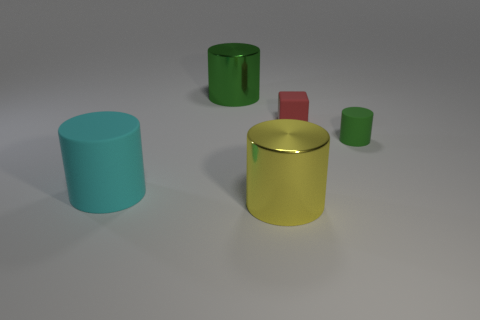Subtract 1 cylinders. How many cylinders are left? 3 Add 4 big yellow cylinders. How many objects exist? 9 Subtract all cylinders. How many objects are left? 1 Add 5 green matte objects. How many green matte objects are left? 6 Add 4 big red cubes. How many big red cubes exist? 4 Subtract 0 blue blocks. How many objects are left? 5 Subtract all shiny objects. Subtract all red objects. How many objects are left? 2 